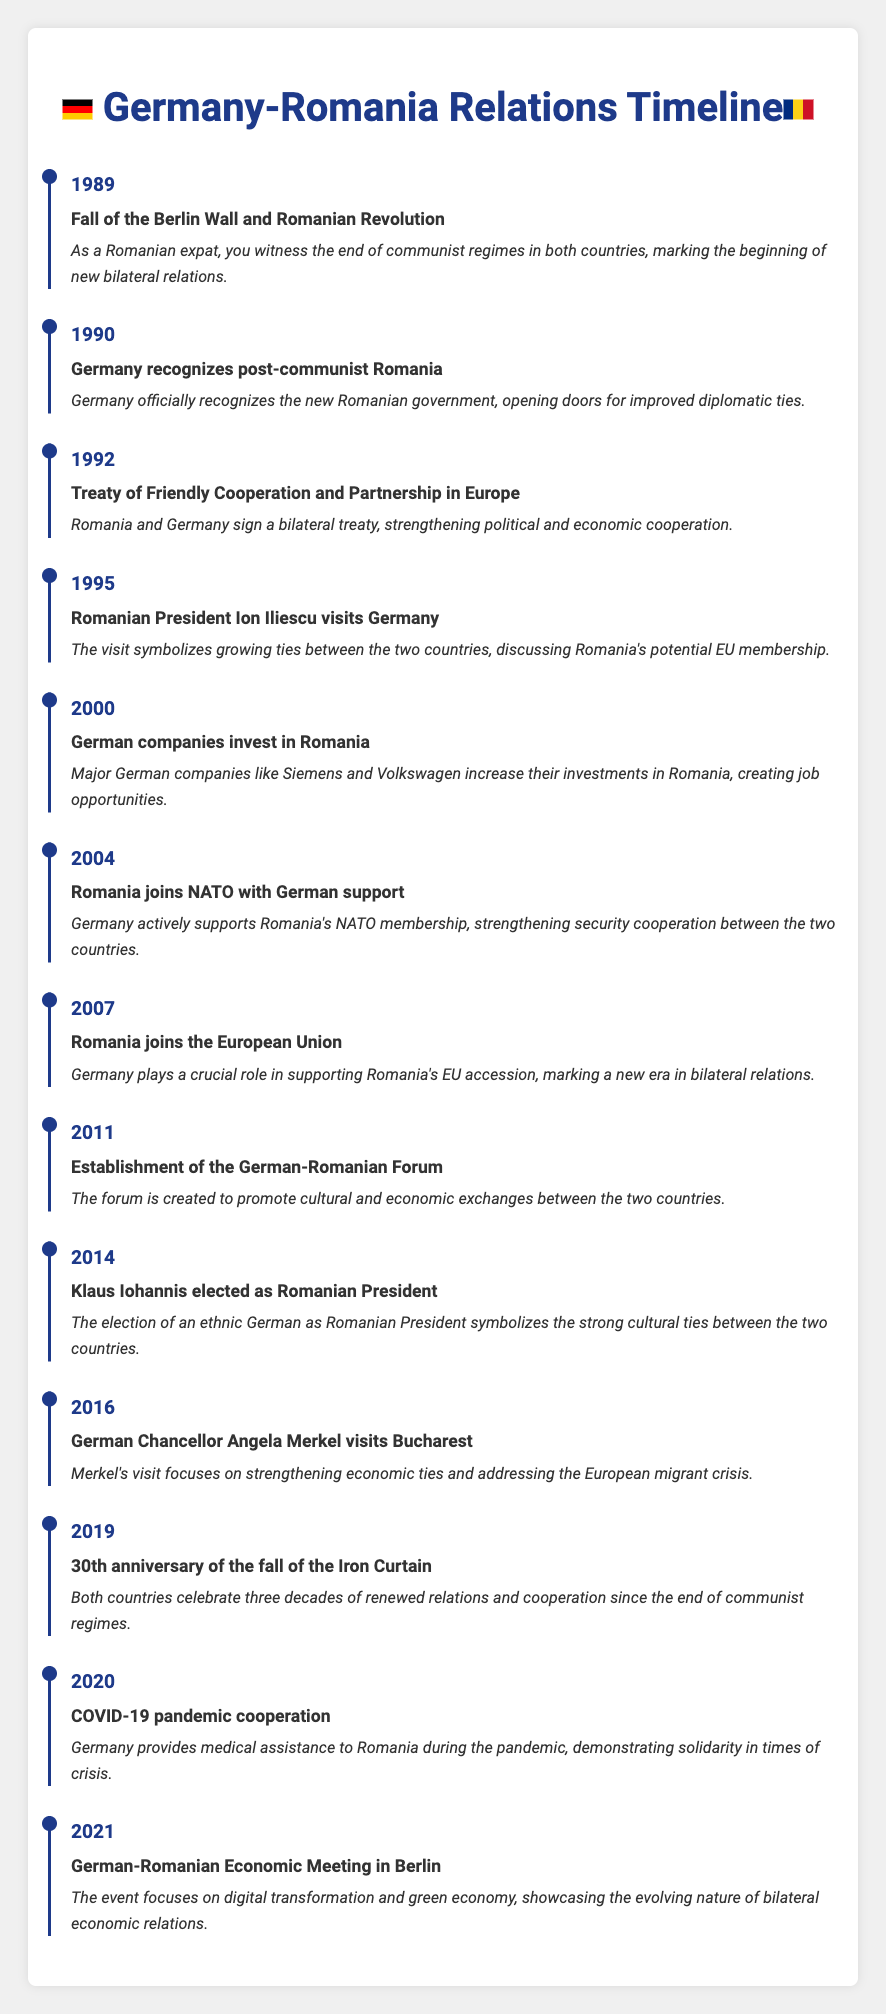What significant event occurred in 1989 concerning both Germany and Romania? In 1989, the Fall of the Berlin Wall and the Romanian Revolution took place, which were significant events that marked the end of communist regimes in both countries. This event signifies the beginning of new bilateral relations between Germany and Romania post-Iron Curtain.
Answer: The fall of the Berlin Wall and Romanian Revolution When did Germany officially recognize the new Romanian government? According to the timeline, in 1990, Germany recognized the post-communist Romanian government, which was an important step in establishing diplomatic relations between the two countries.
Answer: In 1990 What was the outcome of Romanian President Ion Iliescu's visit to Germany in 1995? The visit of Romanian President Ion Iliescu in 1995 symbolized the growing ties between Romania and Germany, during which they discussed Romania's potential EU membership, indicating increased collaboration.
Answer: It symbolized growing ties and discussions about EU membership How many years passed between Romania's NATO membership and its EU accession? Romania joined NATO in 2004 and joined the European Union in 2007. The difference between these years is 3 years, indicating the timeline of Romania's integration into European structures.
Answer: 3 years Did Germany provide assistance to Romania during the COVID-19 pandemic? Yes, the timeline notes that in 2020, Germany provided medical assistance to Romania during the COVID-19 pandemic, demonstrating solidarity in times of crisis.
Answer: Yes What event highlighted the strong cultural ties between Germany and Romania in 2014? Klaus Iohannis, an ethnic German, was elected as the Romanian President, which highlighted the strong cultural ties between the two countries and was seen as a significant milestone in bilateral relations.
Answer: Klaus Iohannis's election as Romanian President Which event in 2011 aimed to promote cultural and economic exchanges between Germany and Romania? The establishment of the German-Romanian Forum in 2011 was designed to promote cultural and economic exchanges, providing a platform for collaboration between both nations.
Answer: Establishment of the German-Romanian Forum in 2011 How did the events of 2019 relate to the history of bilateral relations between Germany and Romania? The year 2019 marked the 30th anniversary of the fall of the Iron Curtain, a significant milestone that both countries celebrated, reflecting on three decades of renewed relations after the communist regimes.
Answer: 30th anniversary of the fall of the Iron Curtain What was the focus of the German-Romanian Economic Meeting in Berlin in 2021? The meeting in 2021 focused on topics like digital transformation and green economy, showcasing the evolving nature of economic relations between Germany and Romania as they adapt to new challenges.
Answer: Digital transformation and green economy 